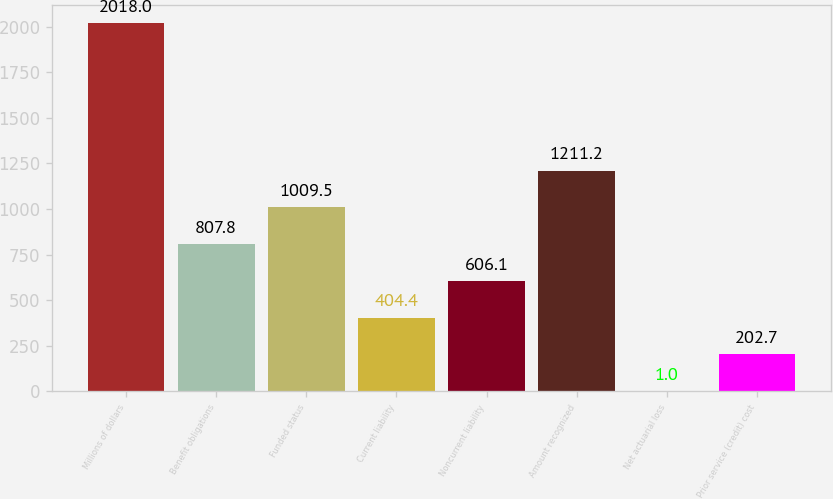Convert chart. <chart><loc_0><loc_0><loc_500><loc_500><bar_chart><fcel>Millions of dollars<fcel>Benefit obligations<fcel>Funded status<fcel>Current liability<fcel>Noncurrent liability<fcel>Amount recognized<fcel>Net actuarial loss<fcel>Prior service (credit) cost<nl><fcel>2018<fcel>807.8<fcel>1009.5<fcel>404.4<fcel>606.1<fcel>1211.2<fcel>1<fcel>202.7<nl></chart> 